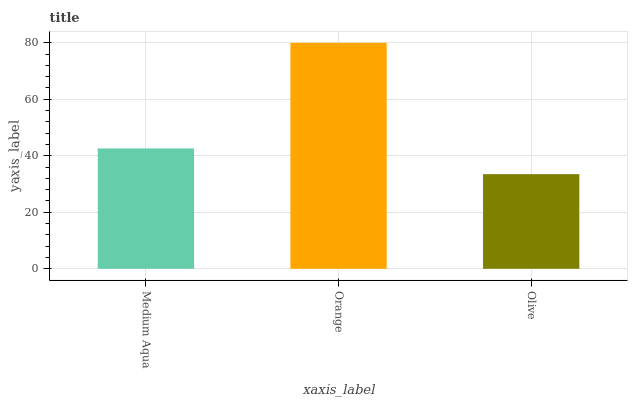Is Olive the minimum?
Answer yes or no. Yes. Is Orange the maximum?
Answer yes or no. Yes. Is Orange the minimum?
Answer yes or no. No. Is Olive the maximum?
Answer yes or no. No. Is Orange greater than Olive?
Answer yes or no. Yes. Is Olive less than Orange?
Answer yes or no. Yes. Is Olive greater than Orange?
Answer yes or no. No. Is Orange less than Olive?
Answer yes or no. No. Is Medium Aqua the high median?
Answer yes or no. Yes. Is Medium Aqua the low median?
Answer yes or no. Yes. Is Orange the high median?
Answer yes or no. No. Is Olive the low median?
Answer yes or no. No. 